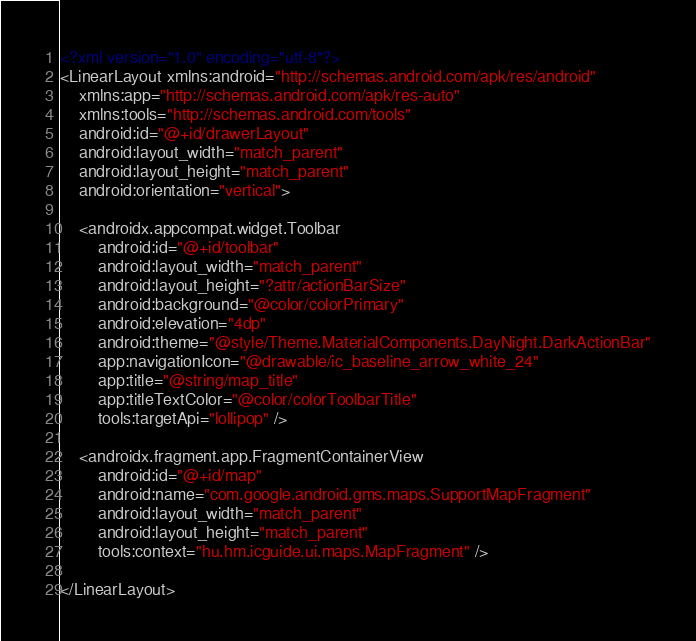Convert code to text. <code><loc_0><loc_0><loc_500><loc_500><_XML_><?xml version="1.0" encoding="utf-8"?>
<LinearLayout xmlns:android="http://schemas.android.com/apk/res/android"
    xmlns:app="http://schemas.android.com/apk/res-auto"
    xmlns:tools="http://schemas.android.com/tools"
    android:id="@+id/drawerLayout"
    android:layout_width="match_parent"
    android:layout_height="match_parent"
    android:orientation="vertical">

    <androidx.appcompat.widget.Toolbar
        android:id="@+id/toolbar"
        android:layout_width="match_parent"
        android:layout_height="?attr/actionBarSize"
        android:background="@color/colorPrimary"
        android:elevation="4dp"
        android:theme="@style/Theme.MaterialComponents.DayNight.DarkActionBar"
        app:navigationIcon="@drawable/ic_baseline_arrow_white_24"
        app:title="@string/map_title"
        app:titleTextColor="@color/colorToolbarTitle"
        tools:targetApi="lollipop" />

    <androidx.fragment.app.FragmentContainerView
        android:id="@+id/map"
        android:name="com.google.android.gms.maps.SupportMapFragment"
        android:layout_width="match_parent"
        android:layout_height="match_parent"
        tools:context="hu.hm.icguide.ui.maps.MapFragment" />

</LinearLayout></code> 